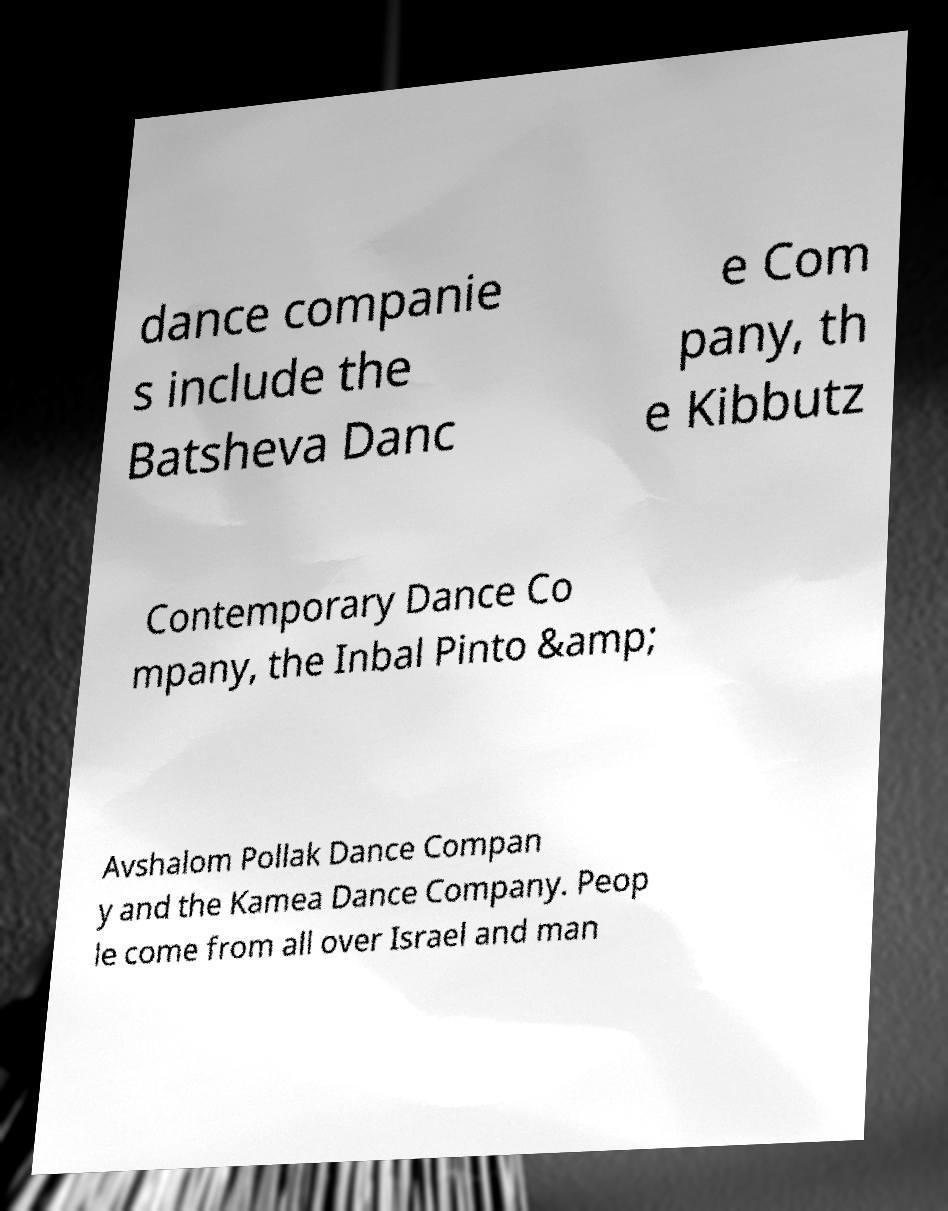Could you extract and type out the text from this image? dance companie s include the Batsheva Danc e Com pany, th e Kibbutz Contemporary Dance Co mpany, the Inbal Pinto &amp; Avshalom Pollak Dance Compan y and the Kamea Dance Company. Peop le come from all over Israel and man 